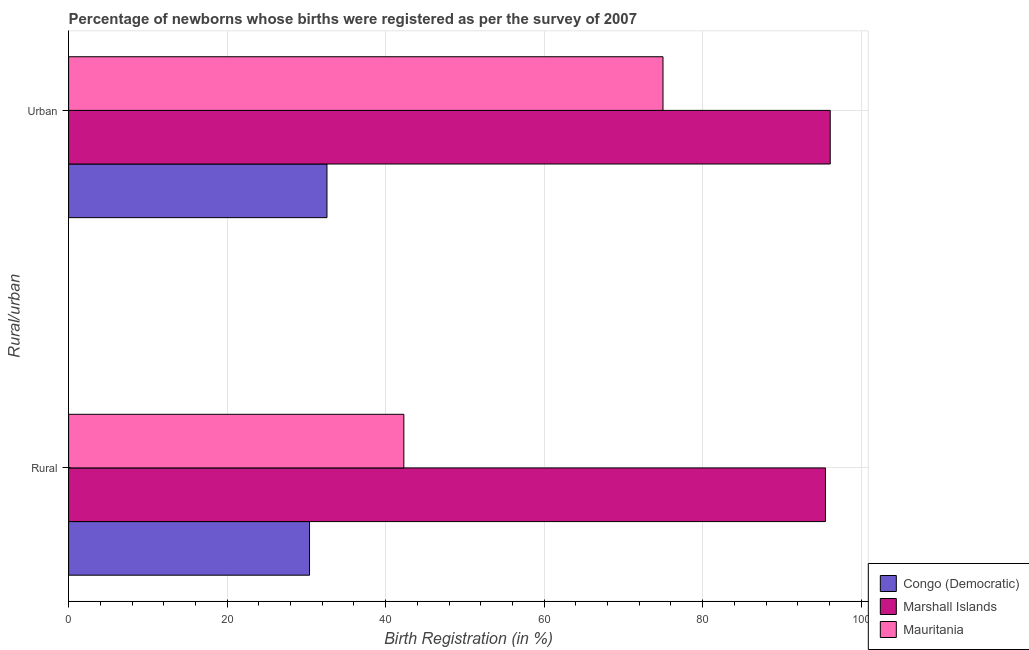Are the number of bars per tick equal to the number of legend labels?
Keep it short and to the point. Yes. Are the number of bars on each tick of the Y-axis equal?
Your answer should be very brief. Yes. How many bars are there on the 2nd tick from the top?
Offer a terse response. 3. What is the label of the 2nd group of bars from the top?
Give a very brief answer. Rural. What is the rural birth registration in Mauritania?
Ensure brevity in your answer.  42.3. Across all countries, what is the maximum rural birth registration?
Make the answer very short. 95.5. Across all countries, what is the minimum urban birth registration?
Keep it short and to the point. 32.6. In which country was the urban birth registration maximum?
Offer a very short reply. Marshall Islands. In which country was the urban birth registration minimum?
Ensure brevity in your answer.  Congo (Democratic). What is the total urban birth registration in the graph?
Your response must be concise. 203.7. What is the difference between the rural birth registration in Marshall Islands and that in Mauritania?
Provide a succinct answer. 53.2. What is the difference between the rural birth registration in Congo (Democratic) and the urban birth registration in Mauritania?
Make the answer very short. -44.6. What is the average urban birth registration per country?
Ensure brevity in your answer.  67.9. What is the difference between the urban birth registration and rural birth registration in Marshall Islands?
Make the answer very short. 0.6. What is the ratio of the urban birth registration in Marshall Islands to that in Congo (Democratic)?
Ensure brevity in your answer.  2.95. In how many countries, is the rural birth registration greater than the average rural birth registration taken over all countries?
Your answer should be very brief. 1. What does the 3rd bar from the top in Rural represents?
Make the answer very short. Congo (Democratic). What does the 2nd bar from the bottom in Rural represents?
Keep it short and to the point. Marshall Islands. How many countries are there in the graph?
Your response must be concise. 3. What is the difference between two consecutive major ticks on the X-axis?
Keep it short and to the point. 20. Where does the legend appear in the graph?
Offer a terse response. Bottom right. How are the legend labels stacked?
Your answer should be compact. Vertical. What is the title of the graph?
Your answer should be very brief. Percentage of newborns whose births were registered as per the survey of 2007. What is the label or title of the X-axis?
Offer a terse response. Birth Registration (in %). What is the label or title of the Y-axis?
Ensure brevity in your answer.  Rural/urban. What is the Birth Registration (in %) of Congo (Democratic) in Rural?
Offer a very short reply. 30.4. What is the Birth Registration (in %) in Marshall Islands in Rural?
Your answer should be compact. 95.5. What is the Birth Registration (in %) in Mauritania in Rural?
Provide a succinct answer. 42.3. What is the Birth Registration (in %) of Congo (Democratic) in Urban?
Offer a very short reply. 32.6. What is the Birth Registration (in %) of Marshall Islands in Urban?
Your response must be concise. 96.1. Across all Rural/urban, what is the maximum Birth Registration (in %) of Congo (Democratic)?
Keep it short and to the point. 32.6. Across all Rural/urban, what is the maximum Birth Registration (in %) of Marshall Islands?
Your answer should be compact. 96.1. Across all Rural/urban, what is the maximum Birth Registration (in %) of Mauritania?
Make the answer very short. 75. Across all Rural/urban, what is the minimum Birth Registration (in %) of Congo (Democratic)?
Your response must be concise. 30.4. Across all Rural/urban, what is the minimum Birth Registration (in %) in Marshall Islands?
Provide a succinct answer. 95.5. Across all Rural/urban, what is the minimum Birth Registration (in %) in Mauritania?
Ensure brevity in your answer.  42.3. What is the total Birth Registration (in %) in Marshall Islands in the graph?
Provide a short and direct response. 191.6. What is the total Birth Registration (in %) of Mauritania in the graph?
Make the answer very short. 117.3. What is the difference between the Birth Registration (in %) in Mauritania in Rural and that in Urban?
Provide a succinct answer. -32.7. What is the difference between the Birth Registration (in %) in Congo (Democratic) in Rural and the Birth Registration (in %) in Marshall Islands in Urban?
Provide a short and direct response. -65.7. What is the difference between the Birth Registration (in %) of Congo (Democratic) in Rural and the Birth Registration (in %) of Mauritania in Urban?
Provide a succinct answer. -44.6. What is the difference between the Birth Registration (in %) in Marshall Islands in Rural and the Birth Registration (in %) in Mauritania in Urban?
Provide a short and direct response. 20.5. What is the average Birth Registration (in %) in Congo (Democratic) per Rural/urban?
Offer a very short reply. 31.5. What is the average Birth Registration (in %) in Marshall Islands per Rural/urban?
Provide a short and direct response. 95.8. What is the average Birth Registration (in %) of Mauritania per Rural/urban?
Your response must be concise. 58.65. What is the difference between the Birth Registration (in %) in Congo (Democratic) and Birth Registration (in %) in Marshall Islands in Rural?
Keep it short and to the point. -65.1. What is the difference between the Birth Registration (in %) of Congo (Democratic) and Birth Registration (in %) of Mauritania in Rural?
Ensure brevity in your answer.  -11.9. What is the difference between the Birth Registration (in %) in Marshall Islands and Birth Registration (in %) in Mauritania in Rural?
Keep it short and to the point. 53.2. What is the difference between the Birth Registration (in %) of Congo (Democratic) and Birth Registration (in %) of Marshall Islands in Urban?
Your answer should be compact. -63.5. What is the difference between the Birth Registration (in %) in Congo (Democratic) and Birth Registration (in %) in Mauritania in Urban?
Your response must be concise. -42.4. What is the difference between the Birth Registration (in %) of Marshall Islands and Birth Registration (in %) of Mauritania in Urban?
Offer a terse response. 21.1. What is the ratio of the Birth Registration (in %) of Congo (Democratic) in Rural to that in Urban?
Offer a terse response. 0.93. What is the ratio of the Birth Registration (in %) in Mauritania in Rural to that in Urban?
Your answer should be compact. 0.56. What is the difference between the highest and the second highest Birth Registration (in %) of Mauritania?
Offer a very short reply. 32.7. What is the difference between the highest and the lowest Birth Registration (in %) in Mauritania?
Your answer should be compact. 32.7. 